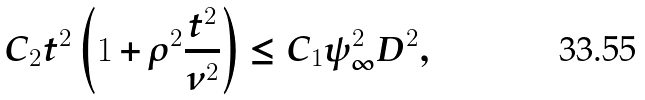<formula> <loc_0><loc_0><loc_500><loc_500>C _ { 2 } t ^ { 2 } \left ( 1 + \rho ^ { 2 } \frac { t ^ { 2 } } { \nu ^ { 2 } } \right ) \leq C _ { 1 } \psi _ { \infty } ^ { 2 } D ^ { 2 } ,</formula> 